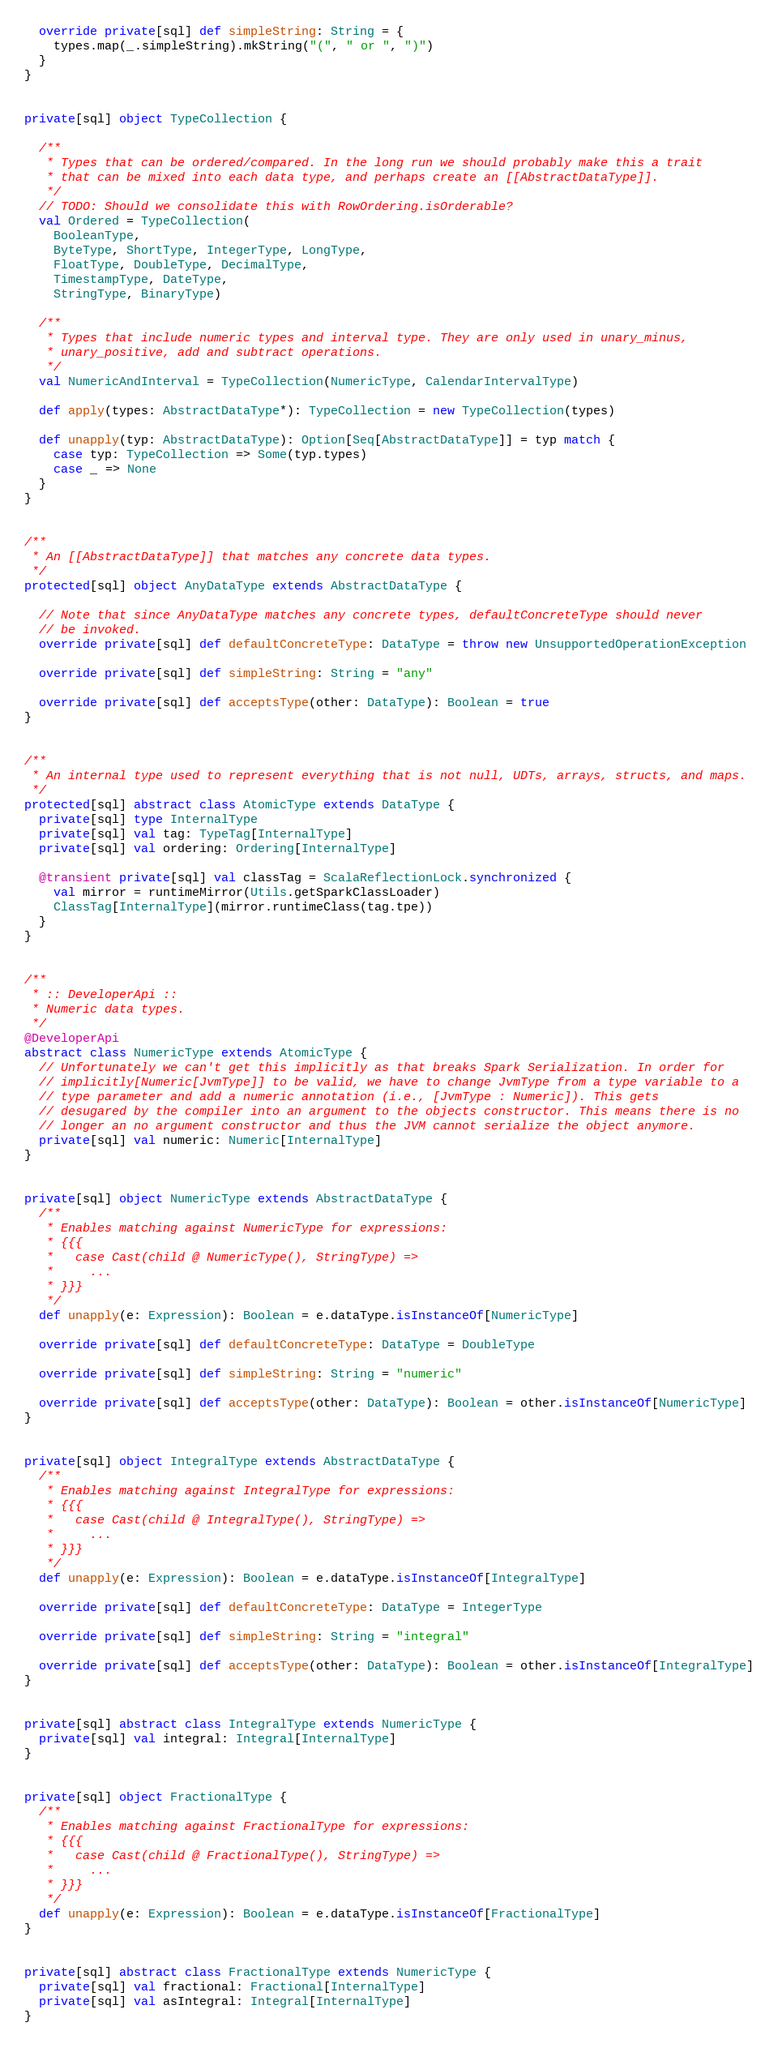<code> <loc_0><loc_0><loc_500><loc_500><_Scala_>
  override private[sql] def simpleString: String = {
    types.map(_.simpleString).mkString("(", " or ", ")")
  }
}


private[sql] object TypeCollection {

  /**
   * Types that can be ordered/compared. In the long run we should probably make this a trait
   * that can be mixed into each data type, and perhaps create an [[AbstractDataType]].
   */
  // TODO: Should we consolidate this with RowOrdering.isOrderable?
  val Ordered = TypeCollection(
    BooleanType,
    ByteType, ShortType, IntegerType, LongType,
    FloatType, DoubleType, DecimalType,
    TimestampType, DateType,
    StringType, BinaryType)

  /**
   * Types that include numeric types and interval type. They are only used in unary_minus,
   * unary_positive, add and subtract operations.
   */
  val NumericAndInterval = TypeCollection(NumericType, CalendarIntervalType)

  def apply(types: AbstractDataType*): TypeCollection = new TypeCollection(types)

  def unapply(typ: AbstractDataType): Option[Seq[AbstractDataType]] = typ match {
    case typ: TypeCollection => Some(typ.types)
    case _ => None
  }
}


/**
 * An [[AbstractDataType]] that matches any concrete data types.
 */
protected[sql] object AnyDataType extends AbstractDataType {

  // Note that since AnyDataType matches any concrete types, defaultConcreteType should never
  // be invoked.
  override private[sql] def defaultConcreteType: DataType = throw new UnsupportedOperationException

  override private[sql] def simpleString: String = "any"

  override private[sql] def acceptsType(other: DataType): Boolean = true
}


/**
 * An internal type used to represent everything that is not null, UDTs, arrays, structs, and maps.
 */
protected[sql] abstract class AtomicType extends DataType {
  private[sql] type InternalType
  private[sql] val tag: TypeTag[InternalType]
  private[sql] val ordering: Ordering[InternalType]

  @transient private[sql] val classTag = ScalaReflectionLock.synchronized {
    val mirror = runtimeMirror(Utils.getSparkClassLoader)
    ClassTag[InternalType](mirror.runtimeClass(tag.tpe))
  }
}


/**
 * :: DeveloperApi ::
 * Numeric data types.
 */
@DeveloperApi
abstract class NumericType extends AtomicType {
  // Unfortunately we can't get this implicitly as that breaks Spark Serialization. In order for
  // implicitly[Numeric[JvmType]] to be valid, we have to change JvmType from a type variable to a
  // type parameter and add a numeric annotation (i.e., [JvmType : Numeric]). This gets
  // desugared by the compiler into an argument to the objects constructor. This means there is no
  // longer an no argument constructor and thus the JVM cannot serialize the object anymore.
  private[sql] val numeric: Numeric[InternalType]
}


private[sql] object NumericType extends AbstractDataType {
  /**
   * Enables matching against NumericType for expressions:
   * {{{
   *   case Cast(child @ NumericType(), StringType) =>
   *     ...
   * }}}
   */
  def unapply(e: Expression): Boolean = e.dataType.isInstanceOf[NumericType]

  override private[sql] def defaultConcreteType: DataType = DoubleType

  override private[sql] def simpleString: String = "numeric"

  override private[sql] def acceptsType(other: DataType): Boolean = other.isInstanceOf[NumericType]
}


private[sql] object IntegralType extends AbstractDataType {
  /**
   * Enables matching against IntegralType for expressions:
   * {{{
   *   case Cast(child @ IntegralType(), StringType) =>
   *     ...
   * }}}
   */
  def unapply(e: Expression): Boolean = e.dataType.isInstanceOf[IntegralType]

  override private[sql] def defaultConcreteType: DataType = IntegerType

  override private[sql] def simpleString: String = "integral"

  override private[sql] def acceptsType(other: DataType): Boolean = other.isInstanceOf[IntegralType]
}


private[sql] abstract class IntegralType extends NumericType {
  private[sql] val integral: Integral[InternalType]
}


private[sql] object FractionalType {
  /**
   * Enables matching against FractionalType for expressions:
   * {{{
   *   case Cast(child @ FractionalType(), StringType) =>
   *     ...
   * }}}
   */
  def unapply(e: Expression): Boolean = e.dataType.isInstanceOf[FractionalType]
}


private[sql] abstract class FractionalType extends NumericType {
  private[sql] val fractional: Fractional[InternalType]
  private[sql] val asIntegral: Integral[InternalType]
}
</code> 